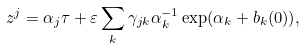Convert formula to latex. <formula><loc_0><loc_0><loc_500><loc_500>z ^ { j } = \alpha _ { j } \tau + \varepsilon \sum _ { k } \gamma _ { j k } \alpha ^ { - 1 } _ { k } \exp ( \alpha _ { k } + b _ { k } ( 0 ) ) ,</formula> 